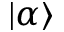<formula> <loc_0><loc_0><loc_500><loc_500>| \alpha \rangle</formula> 